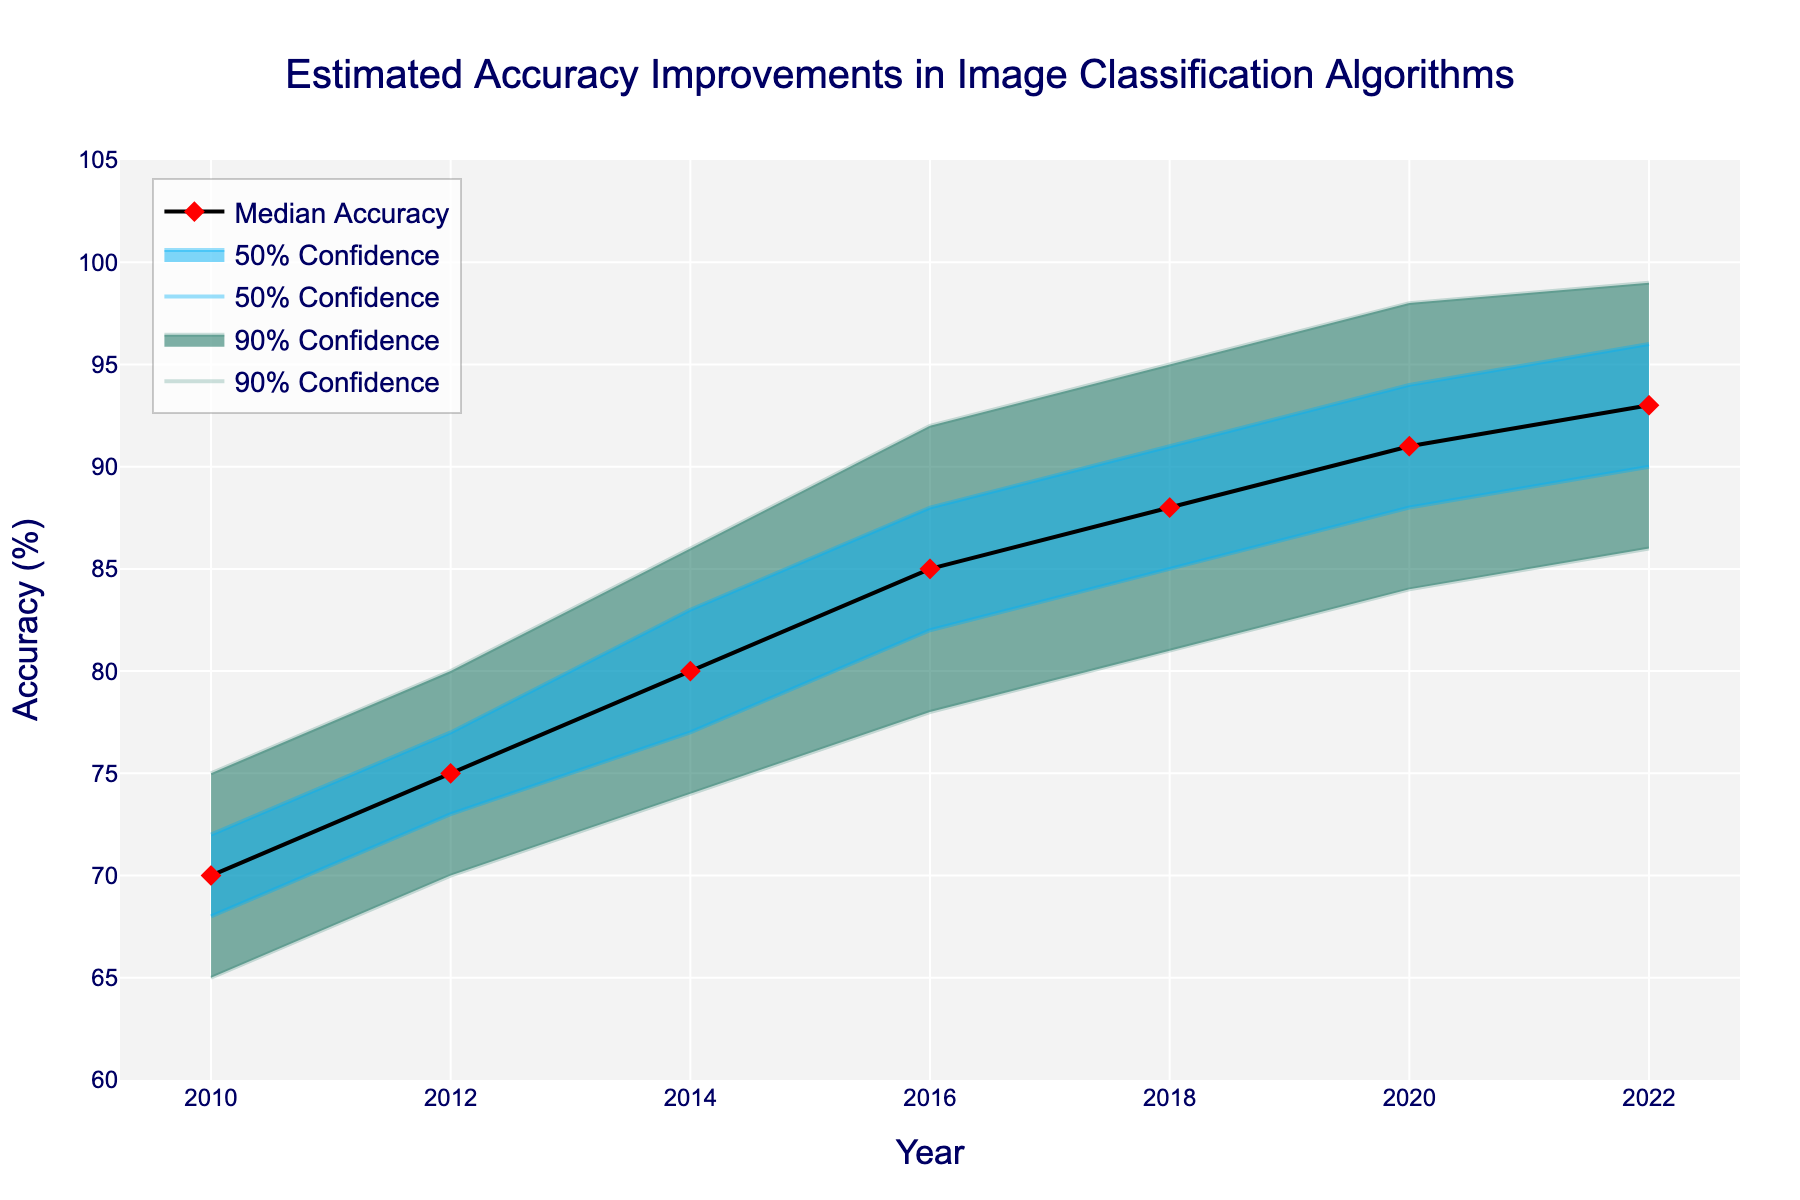What's the title of the figure? The title is displayed at the top of the figure and indicates the main focus of the plot.
Answer: Estimated Accuracy Improvements in Image Classification Algorithms What is the range of years displayed on the x-axis? The x-axis, labeled 'Year', shows the data points over time and spans from the earliest to the latest year in the dataset.
Answer: 2010 to 2022 Which year shows the highest median accuracy? By examining the 'Median Accuracy' line, we can find the year where the median accuracy is the highest.
Answer: 2022 What are the lower and upper bounds of the 90% confidence interval for the accuracy in 2016? The 90% confidence interval is represented by the shaded area between the 'Lower 10th' and 'Upper 10th' lines; locate the values for the year 2016.
Answer: 78% to 92% How much did the median accuracy improve from 2010 to 2022? To find the improvement, subtract the median accuracy in 2010 from the median accuracy in 2022.
Answer: 23% Between 2010 and 2022, which year saw the lowest lower bound of the 50% confidence interval? The 50% confidence interval is between the 'Lower 25th' and 'Upper 75th' lines. Identify the year with the lowest 'Lower 25th' value.
Answer: 2010 What is the difference in the upper 10th bound accuracy between 2018 and 2022? Subtract the upper 10th bound value in 2018 from the value in 2022 to find the difference.
Answer: 4% Is there a noticeable increase in the upper bounds of the 50% confidence interval over the years? By observing the 'Upper 75th' line, we can determine if there is a trend of increasing values.
Answer: Yes What does the shaded area represent in this plot? The shaded areas represent the confidence intervals, with '90% Confidence' and '50% Confidence' indicating the uncertainty ranges around the median accuracy.
Answer: Uncertainty ranges How can we interpret the increasing trend in median accuracy? The overall upward trend in the median accuracy line indicates steady improvements in image classification algorithms over the years.
Answer: Continuous improvement 